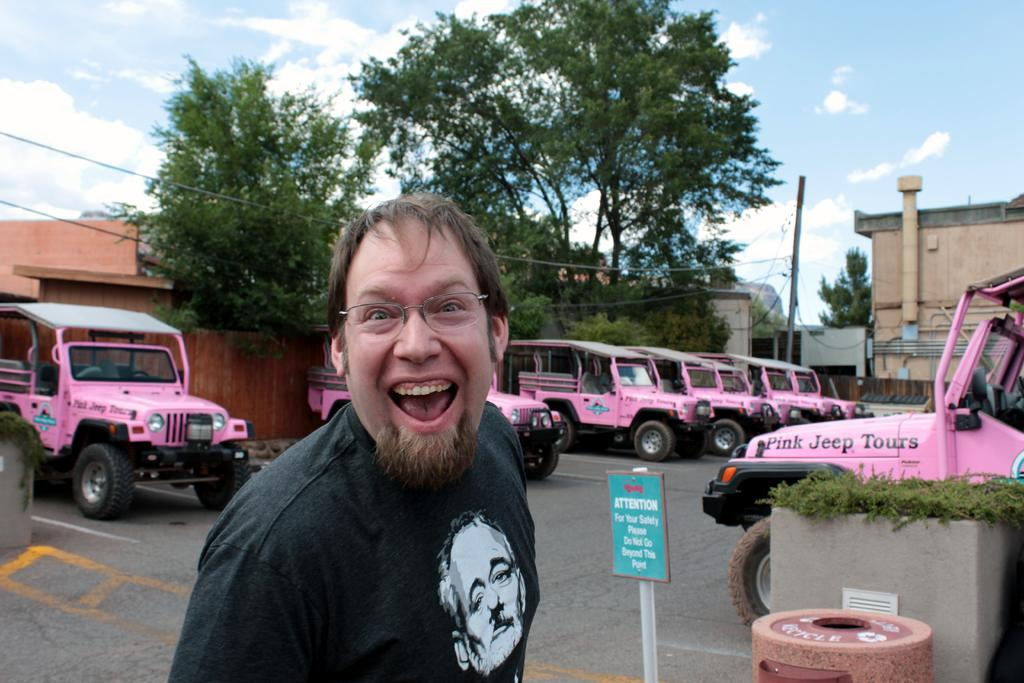Who is the main subject in the foreground of the image? There is a man in the foreground of the image. What vehicles can be seen behind the man? Jeeps are visible behind the man. What safety-related information is conveyed in the image? A caution board is present in the image. What type of natural scenery is visible in the background of the image? There are trees in the background of the image. What type of structures can be seen in the background of the image? There are houses in the background of the image. What type of fowl is perched on the hydrant in the image? There is no hydrant or fowl present in the image. How does the man's throat appear in the image? The image does not provide any information about the man's throat. 